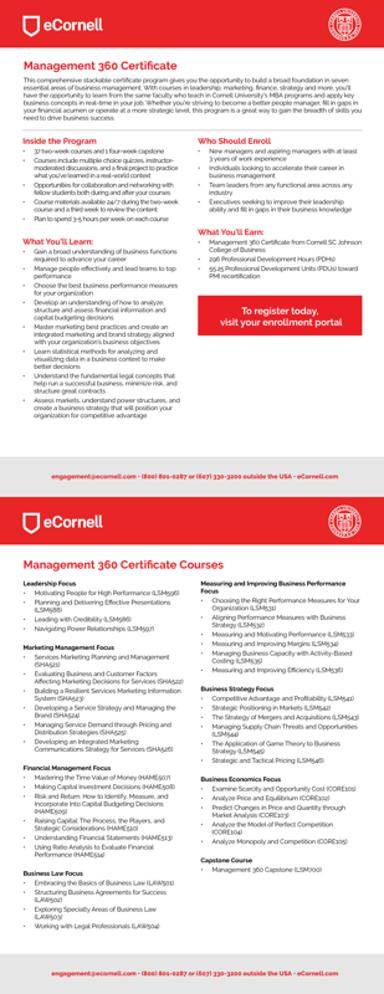What is the main topic of the text in the image? The main topic is the eCornell Management 360 Certificate and its courses. What are some of the courses mentioned in the image? Some of the courses mentioned include Leadership Focus, Moving People for High Performance, Planning and Delivering Effective Presentations, Marketing Planning and Management, Business Strategy Focus, Competitive Advantage and Profitability, Business Economics Focus, and Business Law Focus. What should someone do if they want to register for these courses? To register for these courses, they should visit their enrollment portal as mentioned in the image, which includes a phone number (800-804-0871-607-1330-3200) for further assistance. 